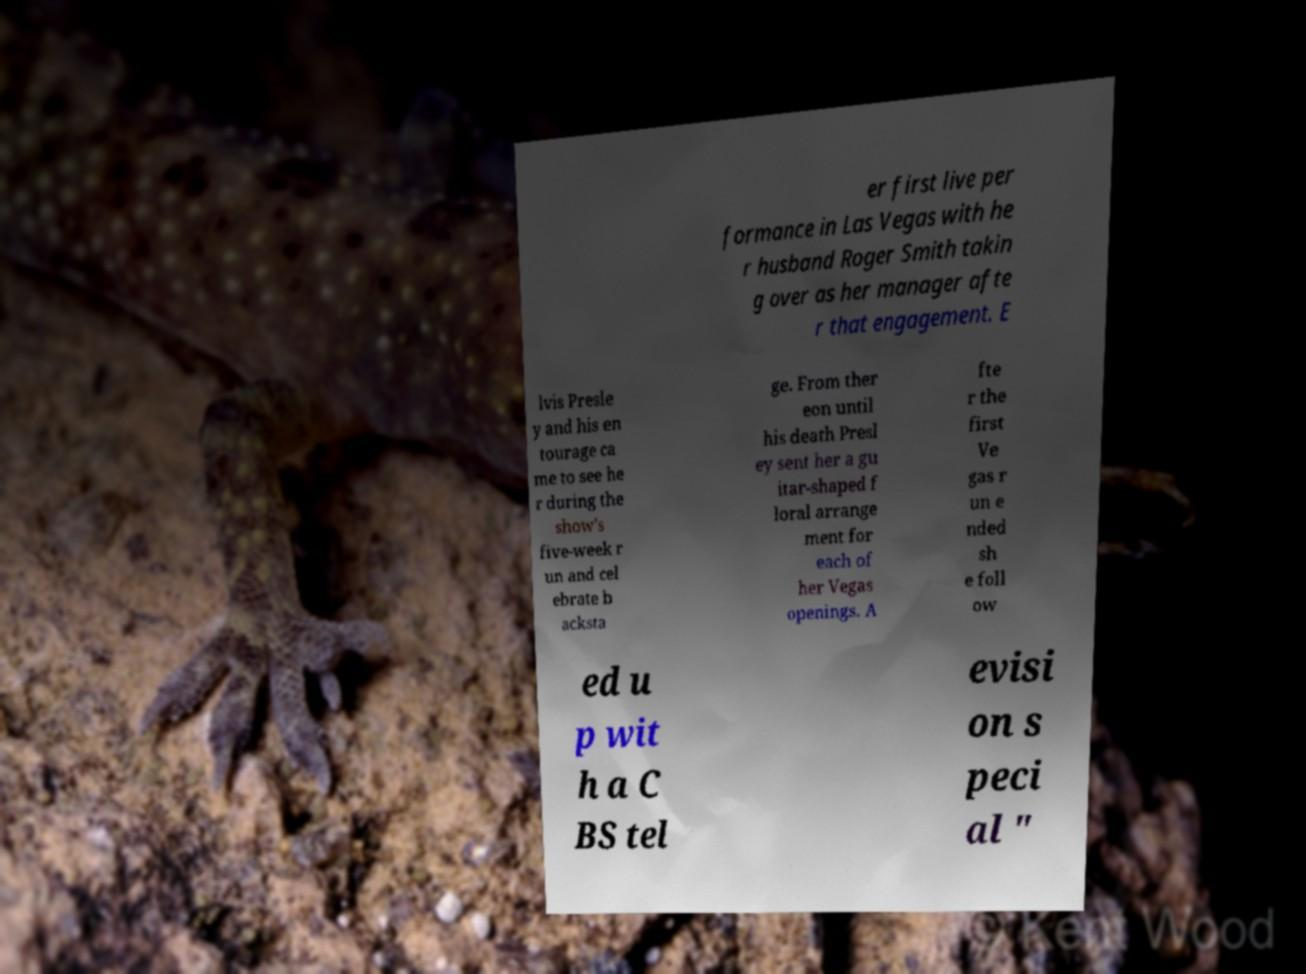Can you accurately transcribe the text from the provided image for me? er first live per formance in Las Vegas with he r husband Roger Smith takin g over as her manager afte r that engagement. E lvis Presle y and his en tourage ca me to see he r during the show's five-week r un and cel ebrate b acksta ge. From ther eon until his death Presl ey sent her a gu itar-shaped f loral arrange ment for each of her Vegas openings. A fte r the first Ve gas r un e nded sh e foll ow ed u p wit h a C BS tel evisi on s peci al " 